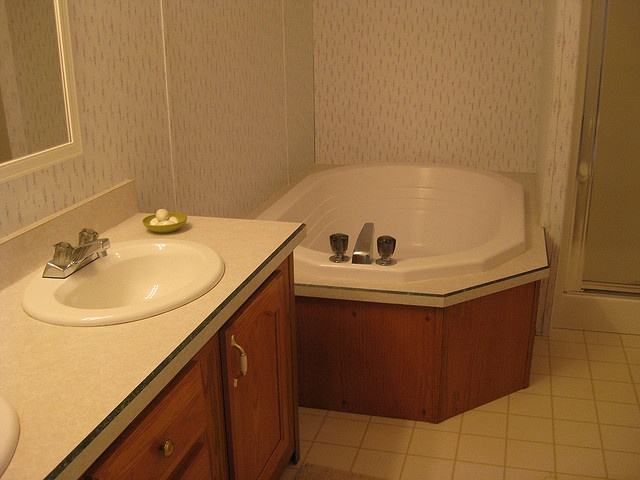Describe the objects in this image and their specific colors. I can see sink in gray and tan tones, sink in gray and tan tones, and bowl in gray, olive, and tan tones in this image. 